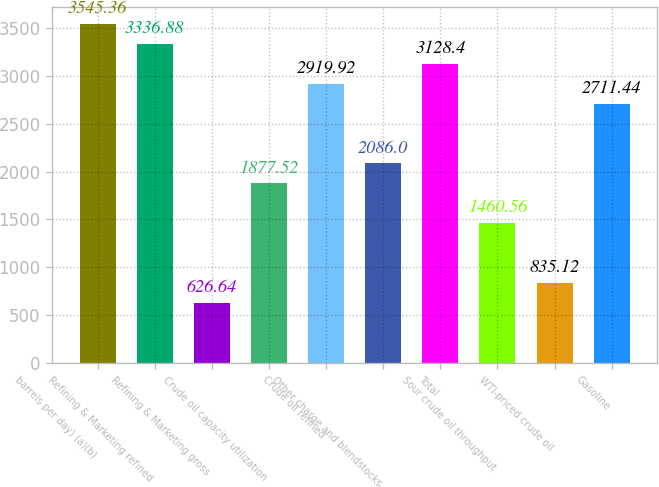Convert chart. <chart><loc_0><loc_0><loc_500><loc_500><bar_chart><fcel>barrels per day) (a)(b)<fcel>Refining & Marketing refined<fcel>Refining & Marketing gross<fcel>Crude oil capacity utilization<fcel>Crude oil refined<fcel>Other charge and blendstocks<fcel>Total<fcel>Sour crude oil throughput<fcel>WTI-priced crude oil<fcel>Gasoline<nl><fcel>3545.36<fcel>3336.88<fcel>626.64<fcel>1877.52<fcel>2919.92<fcel>2086<fcel>3128.4<fcel>1460.56<fcel>835.12<fcel>2711.44<nl></chart> 